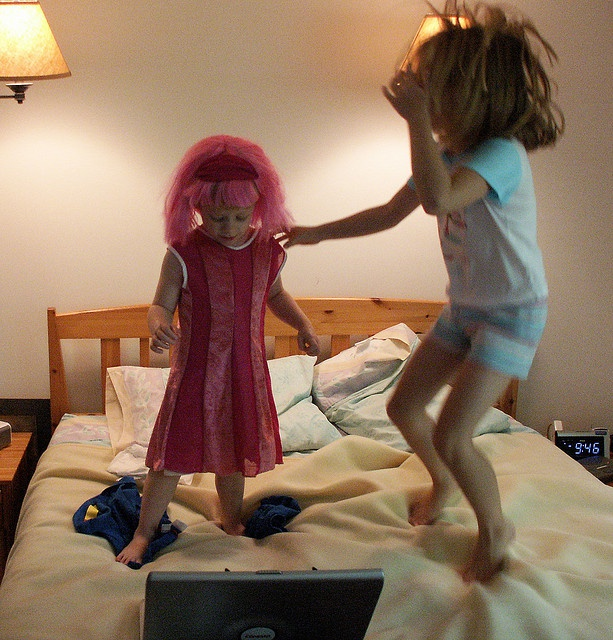Describe the objects in this image and their specific colors. I can see bed in tan, darkgray, and gray tones, people in tan, maroon, black, gray, and olive tones, people in tan, maroon, black, brown, and purple tones, laptop in tan, black, gray, and darkgreen tones, and clock in tan, black, gray, and navy tones in this image. 